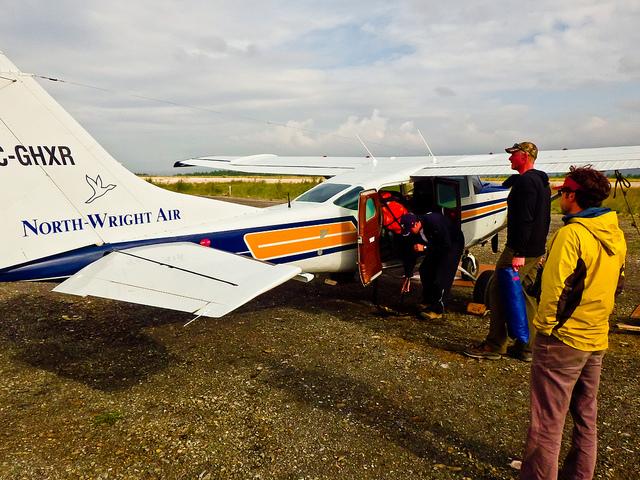Did this plane crash?
Concise answer only. No. What color is the plane?
Be succinct. White. Are they shaking hands?
Keep it brief. No. What color is the man's jacket to the right?
Keep it brief. Yellow. 